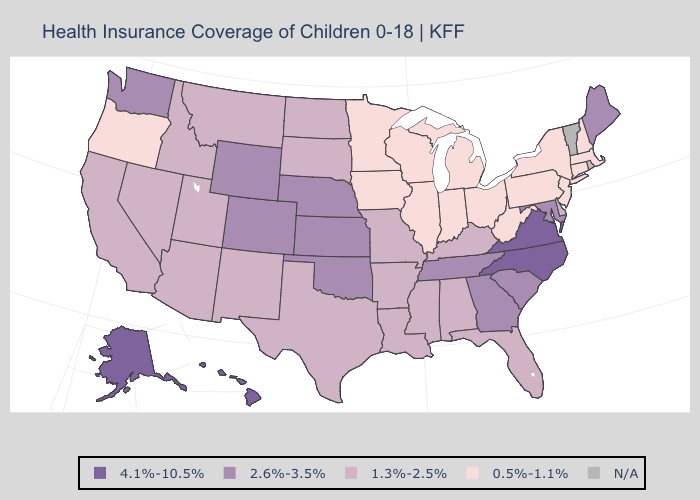Among the states that border Delaware , does Maryland have the highest value?
Answer briefly. Yes. Does the first symbol in the legend represent the smallest category?
Short answer required. No. What is the highest value in states that border West Virginia?
Give a very brief answer. 4.1%-10.5%. What is the lowest value in states that border Tennessee?
Quick response, please. 1.3%-2.5%. Which states have the lowest value in the West?
Keep it brief. Oregon. What is the value of Maine?
Write a very short answer. 2.6%-3.5%. Name the states that have a value in the range 0.5%-1.1%?
Short answer required. Connecticut, Illinois, Indiana, Iowa, Massachusetts, Michigan, Minnesota, New Hampshire, New Jersey, New York, Ohio, Oregon, Pennsylvania, West Virginia, Wisconsin. What is the value of Maine?
Keep it brief. 2.6%-3.5%. Does Maine have the highest value in the Northeast?
Keep it brief. Yes. Name the states that have a value in the range 4.1%-10.5%?
Short answer required. Alaska, Hawaii, North Carolina, Virginia. Name the states that have a value in the range 4.1%-10.5%?
Give a very brief answer. Alaska, Hawaii, North Carolina, Virginia. What is the value of Vermont?
Keep it brief. N/A. Does the map have missing data?
Write a very short answer. Yes. Does the first symbol in the legend represent the smallest category?
Give a very brief answer. No. 